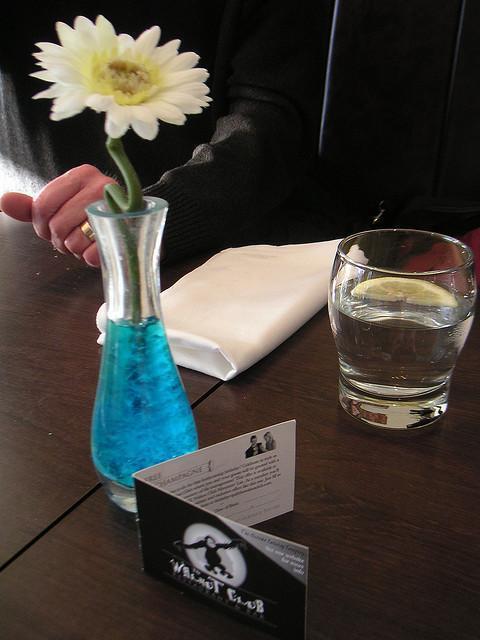How many cars on the locomotive have unprotected wheels?
Give a very brief answer. 0. 